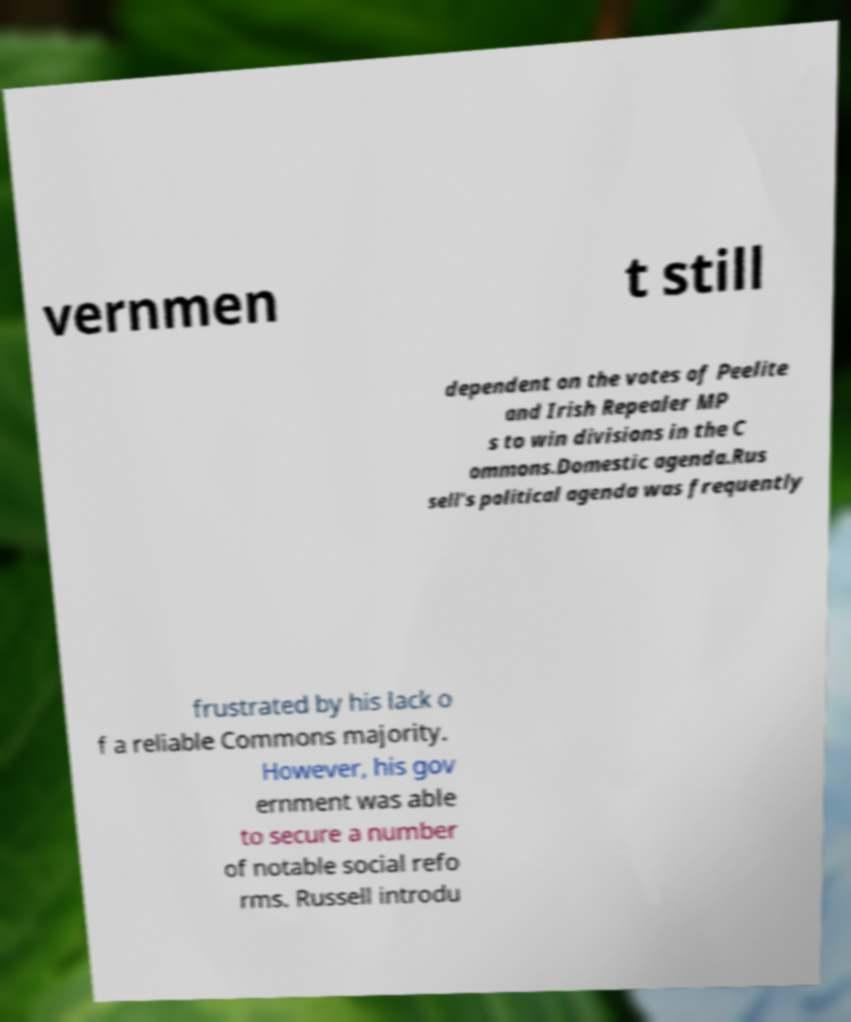Can you accurately transcribe the text from the provided image for me? vernmen t still dependent on the votes of Peelite and Irish Repealer MP s to win divisions in the C ommons.Domestic agenda.Rus sell's political agenda was frequently frustrated by his lack o f a reliable Commons majority. However, his gov ernment was able to secure a number of notable social refo rms. Russell introdu 